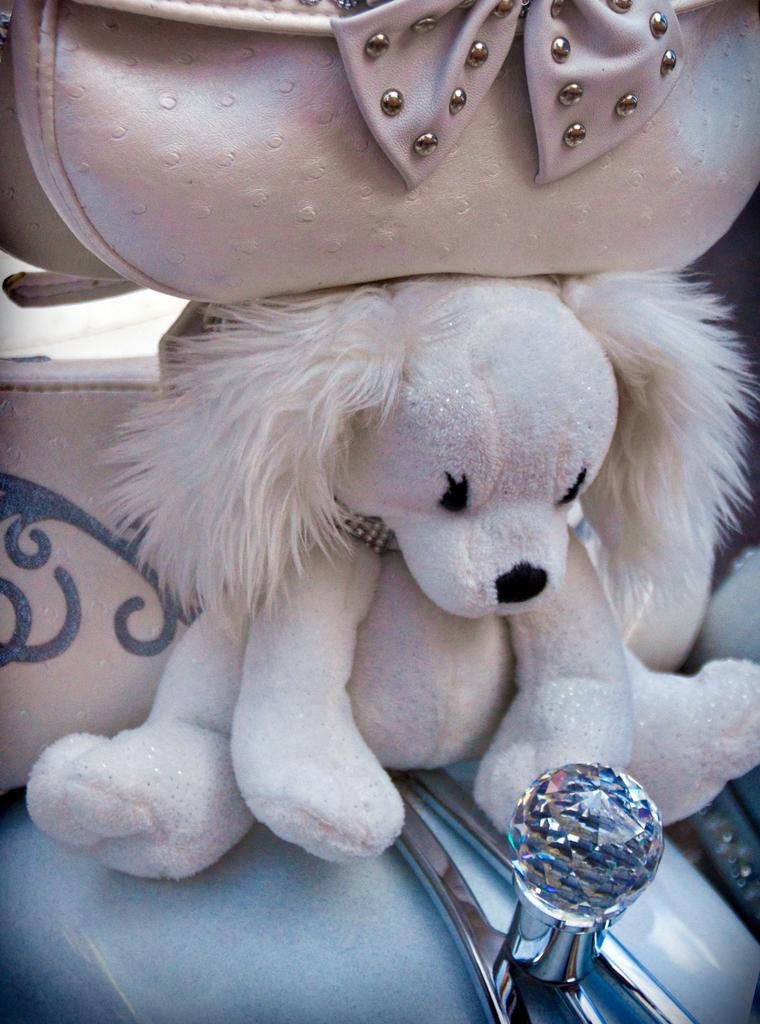What is the main object in the image? There is a doll in the image. What other object is present in the image, and where is it located in relation to the doll? There is a handbag above the doll in the image. Can you describe the setting or location of the doll and handbag? The doll and handbag appear to be on a vehicle. How many cakes are being transported by the cattle in the image? There are no cakes or cattle present in the image. 